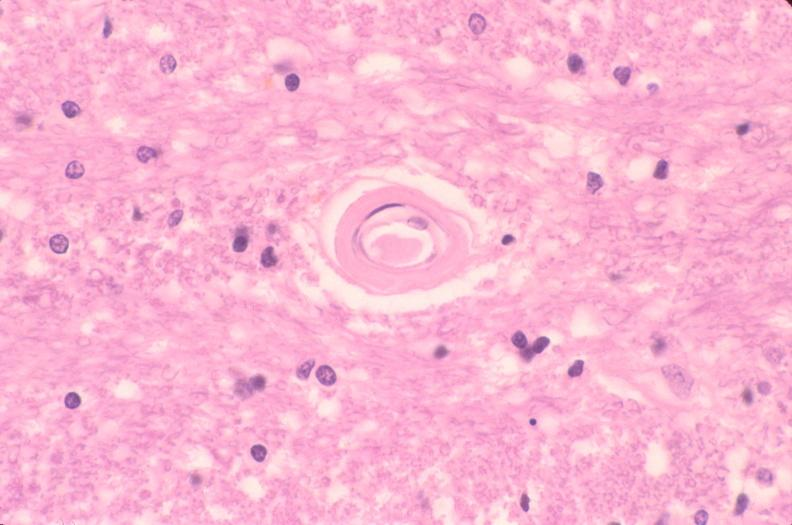does this image show brain, microvessel hyalinization, diabetes mellitus?
Answer the question using a single word or phrase. Yes 